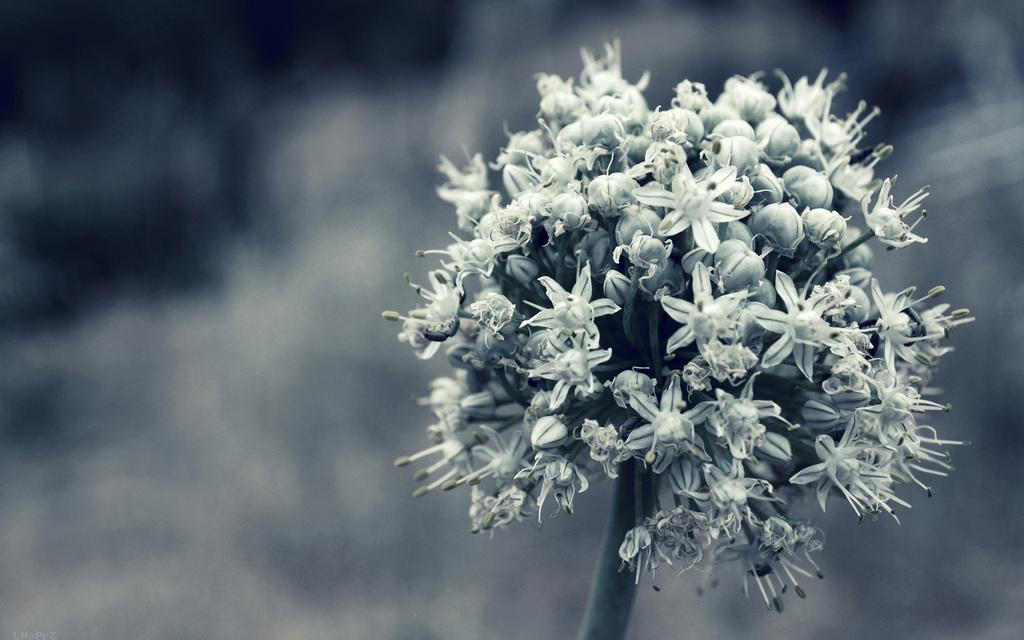What is the main subject of the image? There is a flower in the image. Can you describe the background of the image? The background of the image is blurred. How many leaves can be seen on the flower in the image? The image does not show any leaves on the flower; it only shows the flower itself. What type of produce is visible in the image? There is no produce present in the image. 